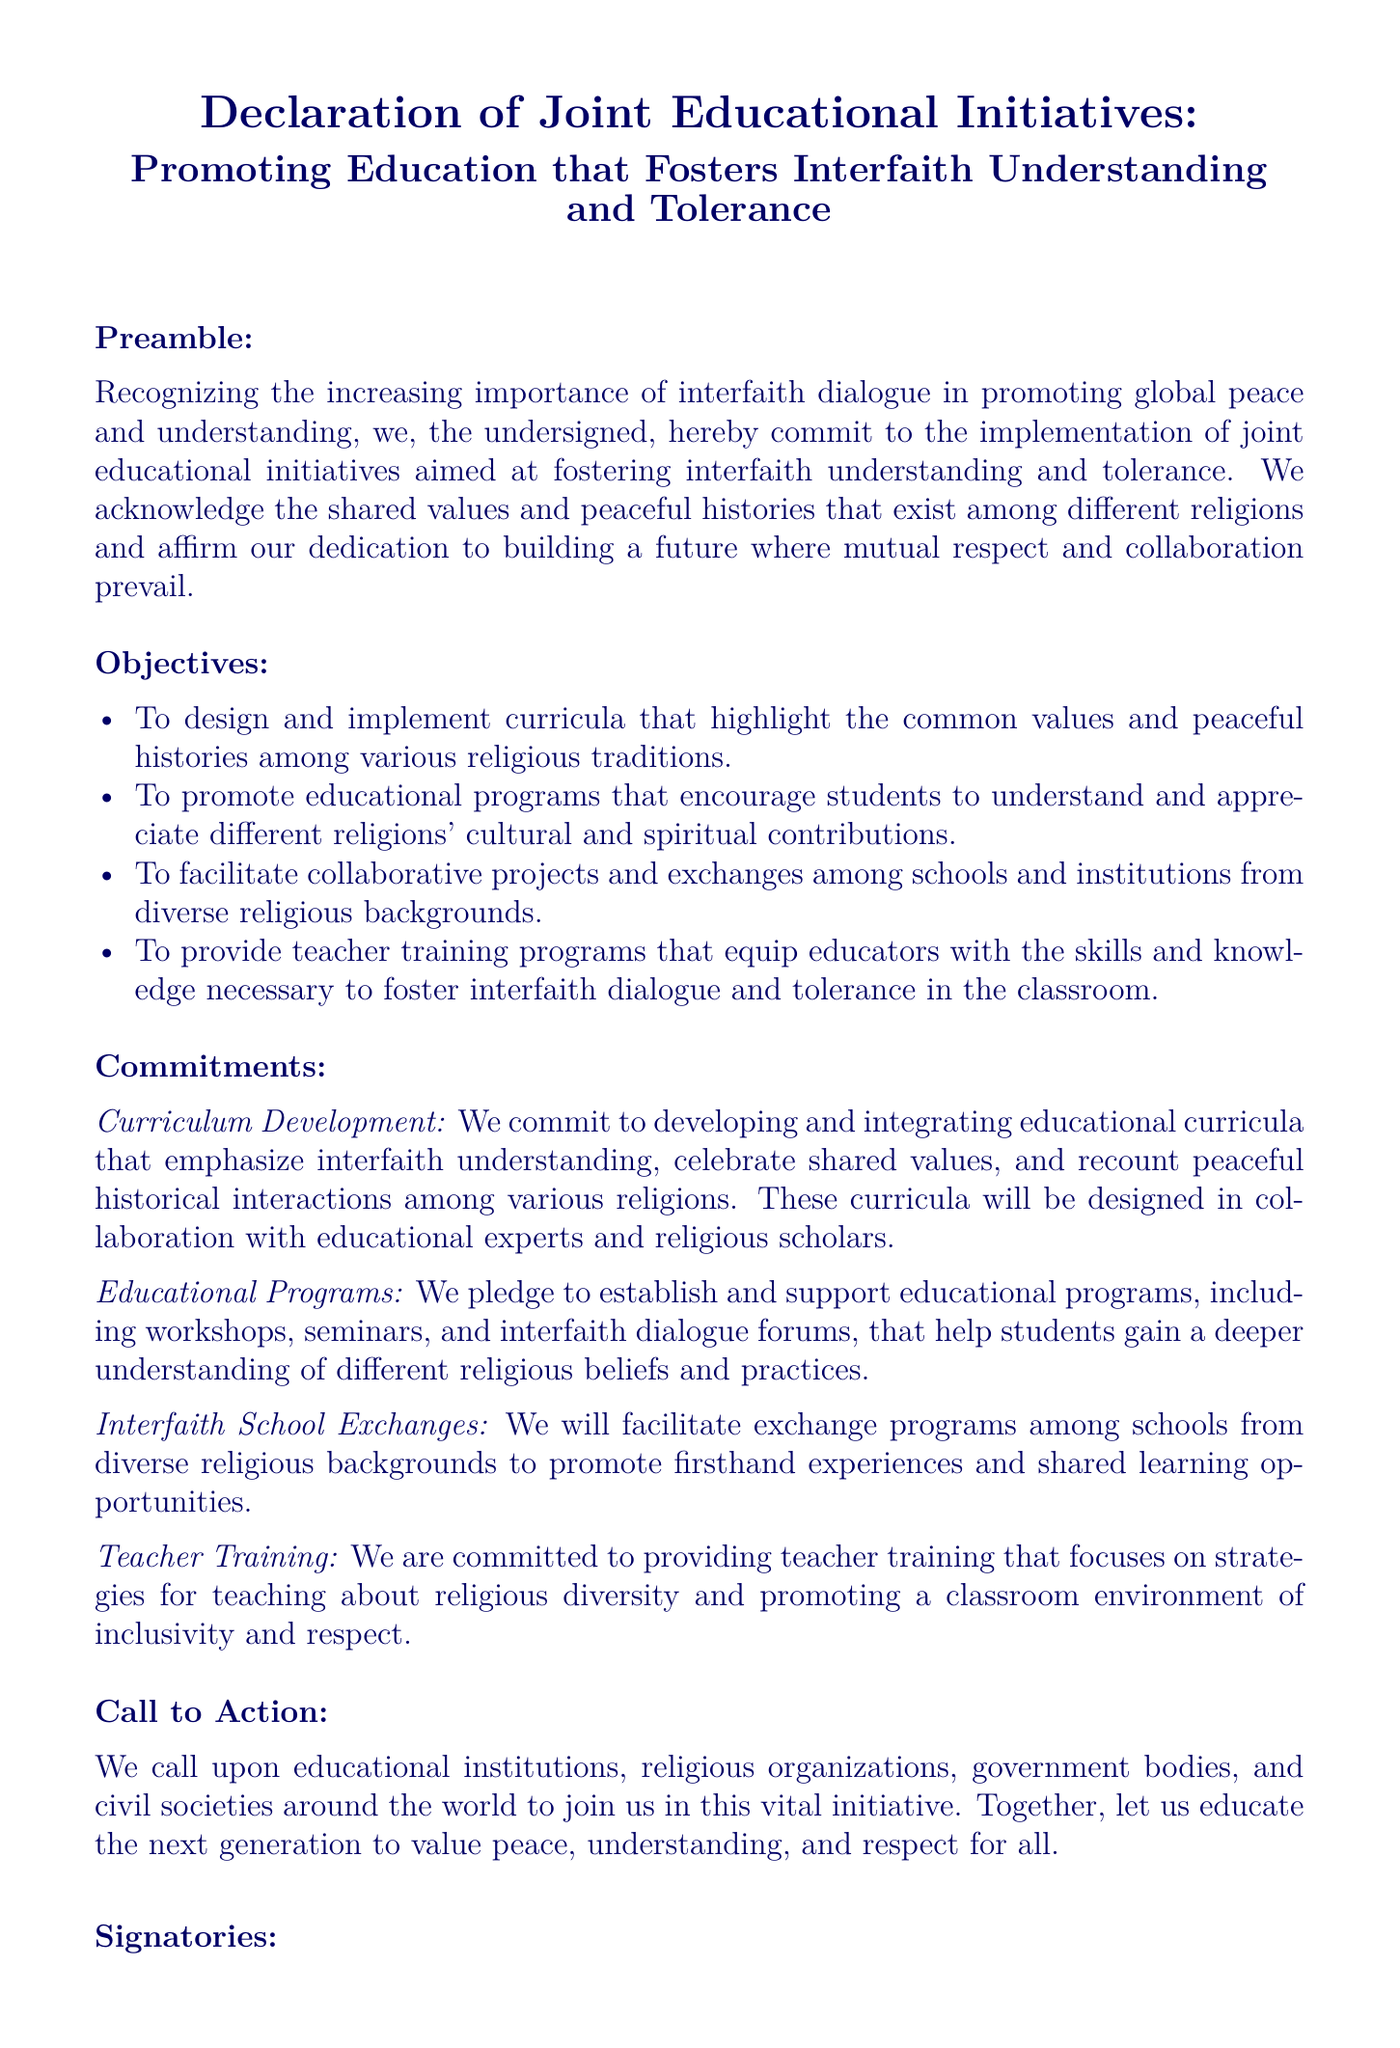What is the title of the document? The title is prominently displayed at the top of the document, introducing the main focus.
Answer: Declaration of Joint Educational Initiatives: Promoting Education that Fosters Interfaith Understanding and Tolerance What is the main goal of the declaration? The main goal is stated in the preamble and aims to promote interfaith understanding and tolerance through education.
Answer: To foster interfaith understanding and tolerance How many objectives are listed in the document? The number of objectives is counted in the "Objectives" section of the document.
Answer: Four What type of educational programs will be established? This relates to the commitment section that describes the types of programs to be created for education purposes.
Answer: Workshops, seminars, and interfaith dialogue forums Who is the signatory of the declaration? The signatory is identified in the closing section of the document, indicating authority.
Answer: President of the Interfaith Council What is mentioned as a method to promote shared learning? This method is detailed in the commitments section that outlines collaborative initiatives among different educational institutions.
Answer: Interfaith School Exchanges What will the teacher training focus on? The focus of the teacher training program is stated clearly in the commitments section of the document.
Answer: Strategies for teaching about religious diversity What is the call to action directed towards? The "Call to Action" section specifies the intended audience for collaboration on the initiative.
Answer: Educational institutions, religious organizations, government bodies, and civil societies 